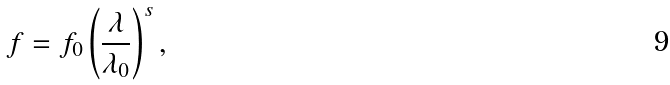Convert formula to latex. <formula><loc_0><loc_0><loc_500><loc_500>f = f _ { 0 } \left ( \frac { \lambda } { \lambda _ { 0 } } \right ) ^ { s } ,</formula> 